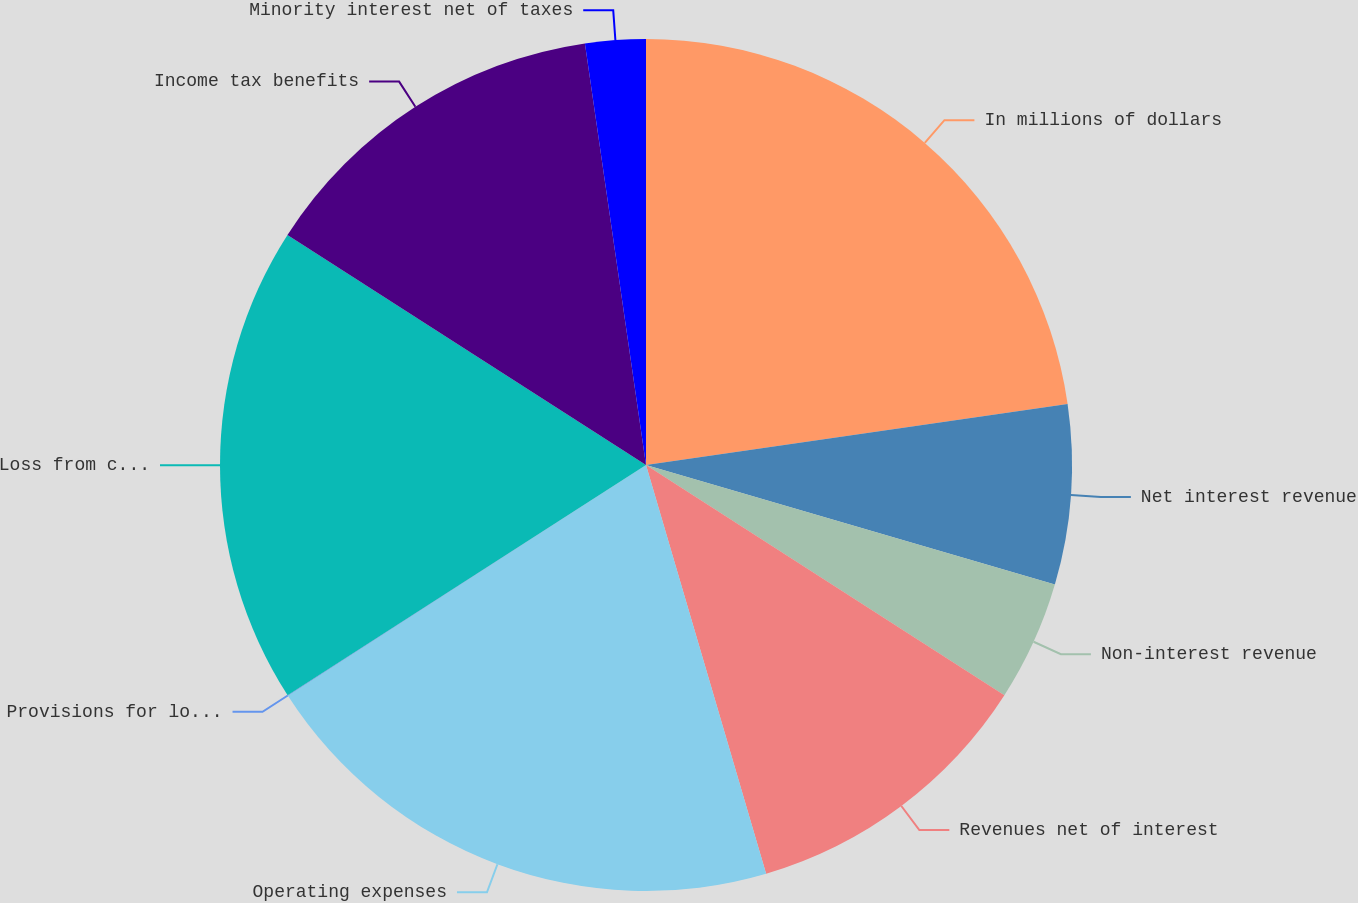Convert chart. <chart><loc_0><loc_0><loc_500><loc_500><pie_chart><fcel>In millions of dollars<fcel>Net interest revenue<fcel>Non-interest revenue<fcel>Revenues net of interest<fcel>Operating expenses<fcel>Provisions for loan losses and<fcel>Loss from continuing<fcel>Income tax benefits<fcel>Minority interest net of taxes<nl><fcel>22.71%<fcel>6.82%<fcel>4.56%<fcel>11.36%<fcel>20.44%<fcel>0.02%<fcel>18.17%<fcel>13.63%<fcel>2.29%<nl></chart> 